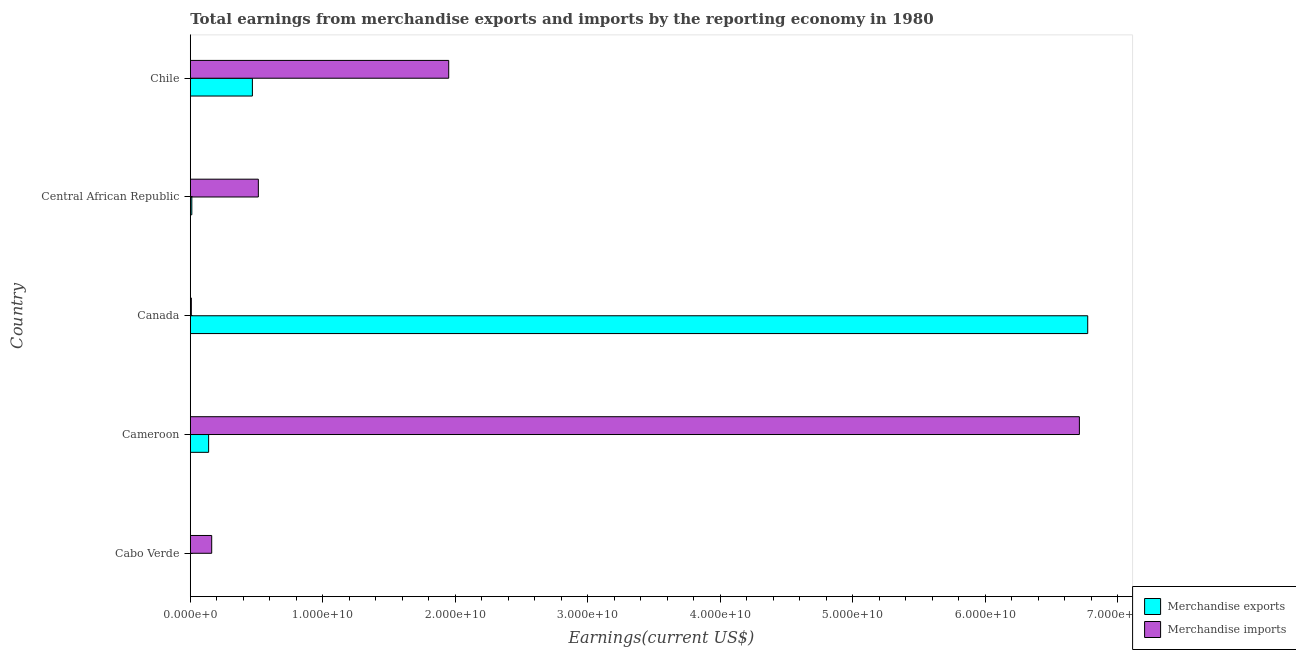How many different coloured bars are there?
Offer a very short reply. 2. How many groups of bars are there?
Your answer should be compact. 5. What is the label of the 5th group of bars from the top?
Your answer should be very brief. Cabo Verde. What is the earnings from merchandise imports in Canada?
Your response must be concise. 7.89e+07. Across all countries, what is the maximum earnings from merchandise exports?
Your answer should be compact. 6.77e+1. Across all countries, what is the minimum earnings from merchandise exports?
Your answer should be compact. 3.80e+06. In which country was the earnings from merchandise exports maximum?
Make the answer very short. Canada. In which country was the earnings from merchandise exports minimum?
Give a very brief answer. Cabo Verde. What is the total earnings from merchandise imports in the graph?
Your answer should be very brief. 9.34e+1. What is the difference between the earnings from merchandise imports in Cabo Verde and that in Chile?
Provide a succinct answer. -1.79e+1. What is the difference between the earnings from merchandise exports in Central African Republic and the earnings from merchandise imports in Cabo Verde?
Provide a short and direct response. -1.50e+09. What is the average earnings from merchandise imports per country?
Offer a very short reply. 1.87e+1. What is the difference between the earnings from merchandise exports and earnings from merchandise imports in Cameroon?
Offer a terse response. -6.57e+1. What is the ratio of the earnings from merchandise exports in Cameroon to that in Central African Republic?
Make the answer very short. 11.93. What is the difference between the highest and the second highest earnings from merchandise imports?
Give a very brief answer. 4.76e+1. What is the difference between the highest and the lowest earnings from merchandise exports?
Provide a short and direct response. 6.77e+1. In how many countries, is the earnings from merchandise imports greater than the average earnings from merchandise imports taken over all countries?
Provide a short and direct response. 2. What does the 2nd bar from the bottom in Chile represents?
Your answer should be very brief. Merchandise imports. Are the values on the major ticks of X-axis written in scientific E-notation?
Provide a short and direct response. Yes. Does the graph contain any zero values?
Your answer should be very brief. No. Where does the legend appear in the graph?
Ensure brevity in your answer.  Bottom right. How many legend labels are there?
Provide a short and direct response. 2. How are the legend labels stacked?
Keep it short and to the point. Vertical. What is the title of the graph?
Give a very brief answer. Total earnings from merchandise exports and imports by the reporting economy in 1980. What is the label or title of the X-axis?
Your response must be concise. Earnings(current US$). What is the Earnings(current US$) in Merchandise exports in Cabo Verde?
Offer a very short reply. 3.80e+06. What is the Earnings(current US$) of Merchandise imports in Cabo Verde?
Your answer should be very brief. 1.62e+09. What is the Earnings(current US$) in Merchandise exports in Cameroon?
Your answer should be compact. 1.38e+09. What is the Earnings(current US$) in Merchandise imports in Cameroon?
Ensure brevity in your answer.  6.71e+1. What is the Earnings(current US$) of Merchandise exports in Canada?
Offer a very short reply. 6.77e+1. What is the Earnings(current US$) in Merchandise imports in Canada?
Offer a very short reply. 7.89e+07. What is the Earnings(current US$) of Merchandise exports in Central African Republic?
Provide a succinct answer. 1.16e+08. What is the Earnings(current US$) of Merchandise imports in Central African Republic?
Offer a terse response. 5.14e+09. What is the Earnings(current US$) of Merchandise exports in Chile?
Ensure brevity in your answer.  4.69e+09. What is the Earnings(current US$) in Merchandise imports in Chile?
Your answer should be compact. 1.95e+1. Across all countries, what is the maximum Earnings(current US$) of Merchandise exports?
Ensure brevity in your answer.  6.77e+1. Across all countries, what is the maximum Earnings(current US$) of Merchandise imports?
Provide a short and direct response. 6.71e+1. Across all countries, what is the minimum Earnings(current US$) of Merchandise exports?
Offer a terse response. 3.80e+06. Across all countries, what is the minimum Earnings(current US$) of Merchandise imports?
Make the answer very short. 7.89e+07. What is the total Earnings(current US$) of Merchandise exports in the graph?
Keep it short and to the point. 7.39e+1. What is the total Earnings(current US$) of Merchandise imports in the graph?
Ensure brevity in your answer.  9.34e+1. What is the difference between the Earnings(current US$) in Merchandise exports in Cabo Verde and that in Cameroon?
Provide a short and direct response. -1.38e+09. What is the difference between the Earnings(current US$) of Merchandise imports in Cabo Verde and that in Cameroon?
Provide a succinct answer. -6.55e+1. What is the difference between the Earnings(current US$) of Merchandise exports in Cabo Verde and that in Canada?
Ensure brevity in your answer.  -6.77e+1. What is the difference between the Earnings(current US$) of Merchandise imports in Cabo Verde and that in Canada?
Your answer should be very brief. 1.54e+09. What is the difference between the Earnings(current US$) of Merchandise exports in Cabo Verde and that in Central African Republic?
Your answer should be very brief. -1.12e+08. What is the difference between the Earnings(current US$) of Merchandise imports in Cabo Verde and that in Central African Republic?
Provide a succinct answer. -3.52e+09. What is the difference between the Earnings(current US$) of Merchandise exports in Cabo Verde and that in Chile?
Provide a short and direct response. -4.68e+09. What is the difference between the Earnings(current US$) of Merchandise imports in Cabo Verde and that in Chile?
Ensure brevity in your answer.  -1.79e+1. What is the difference between the Earnings(current US$) in Merchandise exports in Cameroon and that in Canada?
Your answer should be very brief. -6.63e+1. What is the difference between the Earnings(current US$) in Merchandise imports in Cameroon and that in Canada?
Ensure brevity in your answer.  6.70e+1. What is the difference between the Earnings(current US$) of Merchandise exports in Cameroon and that in Central African Republic?
Your response must be concise. 1.27e+09. What is the difference between the Earnings(current US$) of Merchandise imports in Cameroon and that in Central African Republic?
Provide a short and direct response. 6.20e+1. What is the difference between the Earnings(current US$) of Merchandise exports in Cameroon and that in Chile?
Keep it short and to the point. -3.30e+09. What is the difference between the Earnings(current US$) in Merchandise imports in Cameroon and that in Chile?
Keep it short and to the point. 4.76e+1. What is the difference between the Earnings(current US$) of Merchandise exports in Canada and that in Central African Republic?
Offer a terse response. 6.76e+1. What is the difference between the Earnings(current US$) in Merchandise imports in Canada and that in Central African Republic?
Give a very brief answer. -5.06e+09. What is the difference between the Earnings(current US$) of Merchandise exports in Canada and that in Chile?
Provide a short and direct response. 6.30e+1. What is the difference between the Earnings(current US$) in Merchandise imports in Canada and that in Chile?
Ensure brevity in your answer.  -1.94e+1. What is the difference between the Earnings(current US$) of Merchandise exports in Central African Republic and that in Chile?
Provide a succinct answer. -4.57e+09. What is the difference between the Earnings(current US$) in Merchandise imports in Central African Republic and that in Chile?
Your answer should be very brief. -1.44e+1. What is the difference between the Earnings(current US$) of Merchandise exports in Cabo Verde and the Earnings(current US$) of Merchandise imports in Cameroon?
Your answer should be very brief. -6.71e+1. What is the difference between the Earnings(current US$) in Merchandise exports in Cabo Verde and the Earnings(current US$) in Merchandise imports in Canada?
Offer a terse response. -7.51e+07. What is the difference between the Earnings(current US$) in Merchandise exports in Cabo Verde and the Earnings(current US$) in Merchandise imports in Central African Republic?
Provide a short and direct response. -5.13e+09. What is the difference between the Earnings(current US$) of Merchandise exports in Cabo Verde and the Earnings(current US$) of Merchandise imports in Chile?
Make the answer very short. -1.95e+1. What is the difference between the Earnings(current US$) in Merchandise exports in Cameroon and the Earnings(current US$) in Merchandise imports in Canada?
Your response must be concise. 1.30e+09. What is the difference between the Earnings(current US$) in Merchandise exports in Cameroon and the Earnings(current US$) in Merchandise imports in Central African Republic?
Offer a terse response. -3.75e+09. What is the difference between the Earnings(current US$) in Merchandise exports in Cameroon and the Earnings(current US$) in Merchandise imports in Chile?
Offer a terse response. -1.81e+1. What is the difference between the Earnings(current US$) of Merchandise exports in Canada and the Earnings(current US$) of Merchandise imports in Central African Republic?
Your answer should be very brief. 6.26e+1. What is the difference between the Earnings(current US$) in Merchandise exports in Canada and the Earnings(current US$) in Merchandise imports in Chile?
Ensure brevity in your answer.  4.82e+1. What is the difference between the Earnings(current US$) in Merchandise exports in Central African Republic and the Earnings(current US$) in Merchandise imports in Chile?
Offer a terse response. -1.94e+1. What is the average Earnings(current US$) in Merchandise exports per country?
Offer a very short reply. 1.48e+1. What is the average Earnings(current US$) in Merchandise imports per country?
Offer a very short reply. 1.87e+1. What is the difference between the Earnings(current US$) of Merchandise exports and Earnings(current US$) of Merchandise imports in Cabo Verde?
Provide a succinct answer. -1.61e+09. What is the difference between the Earnings(current US$) of Merchandise exports and Earnings(current US$) of Merchandise imports in Cameroon?
Offer a terse response. -6.57e+1. What is the difference between the Earnings(current US$) in Merchandise exports and Earnings(current US$) in Merchandise imports in Canada?
Ensure brevity in your answer.  6.77e+1. What is the difference between the Earnings(current US$) in Merchandise exports and Earnings(current US$) in Merchandise imports in Central African Republic?
Ensure brevity in your answer.  -5.02e+09. What is the difference between the Earnings(current US$) in Merchandise exports and Earnings(current US$) in Merchandise imports in Chile?
Give a very brief answer. -1.48e+1. What is the ratio of the Earnings(current US$) of Merchandise exports in Cabo Verde to that in Cameroon?
Your response must be concise. 0. What is the ratio of the Earnings(current US$) of Merchandise imports in Cabo Verde to that in Cameroon?
Your answer should be compact. 0.02. What is the ratio of the Earnings(current US$) of Merchandise exports in Cabo Verde to that in Canada?
Your answer should be compact. 0. What is the ratio of the Earnings(current US$) of Merchandise imports in Cabo Verde to that in Canada?
Provide a succinct answer. 20.48. What is the ratio of the Earnings(current US$) of Merchandise exports in Cabo Verde to that in Central African Republic?
Offer a very short reply. 0.03. What is the ratio of the Earnings(current US$) in Merchandise imports in Cabo Verde to that in Central African Republic?
Keep it short and to the point. 0.31. What is the ratio of the Earnings(current US$) of Merchandise exports in Cabo Verde to that in Chile?
Your response must be concise. 0. What is the ratio of the Earnings(current US$) of Merchandise imports in Cabo Verde to that in Chile?
Offer a terse response. 0.08. What is the ratio of the Earnings(current US$) of Merchandise exports in Cameroon to that in Canada?
Your response must be concise. 0.02. What is the ratio of the Earnings(current US$) of Merchandise imports in Cameroon to that in Canada?
Offer a terse response. 850.27. What is the ratio of the Earnings(current US$) of Merchandise exports in Cameroon to that in Central African Republic?
Offer a terse response. 11.93. What is the ratio of the Earnings(current US$) of Merchandise imports in Cameroon to that in Central African Republic?
Give a very brief answer. 13.07. What is the ratio of the Earnings(current US$) of Merchandise exports in Cameroon to that in Chile?
Your answer should be very brief. 0.3. What is the ratio of the Earnings(current US$) in Merchandise imports in Cameroon to that in Chile?
Offer a very short reply. 3.44. What is the ratio of the Earnings(current US$) in Merchandise exports in Canada to that in Central African Republic?
Ensure brevity in your answer.  583.93. What is the ratio of the Earnings(current US$) of Merchandise imports in Canada to that in Central African Republic?
Provide a short and direct response. 0.02. What is the ratio of the Earnings(current US$) of Merchandise exports in Canada to that in Chile?
Keep it short and to the point. 14.45. What is the ratio of the Earnings(current US$) in Merchandise imports in Canada to that in Chile?
Keep it short and to the point. 0. What is the ratio of the Earnings(current US$) in Merchandise exports in Central African Republic to that in Chile?
Keep it short and to the point. 0.02. What is the ratio of the Earnings(current US$) of Merchandise imports in Central African Republic to that in Chile?
Your response must be concise. 0.26. What is the difference between the highest and the second highest Earnings(current US$) of Merchandise exports?
Offer a terse response. 6.30e+1. What is the difference between the highest and the second highest Earnings(current US$) in Merchandise imports?
Offer a terse response. 4.76e+1. What is the difference between the highest and the lowest Earnings(current US$) of Merchandise exports?
Your answer should be compact. 6.77e+1. What is the difference between the highest and the lowest Earnings(current US$) of Merchandise imports?
Ensure brevity in your answer.  6.70e+1. 